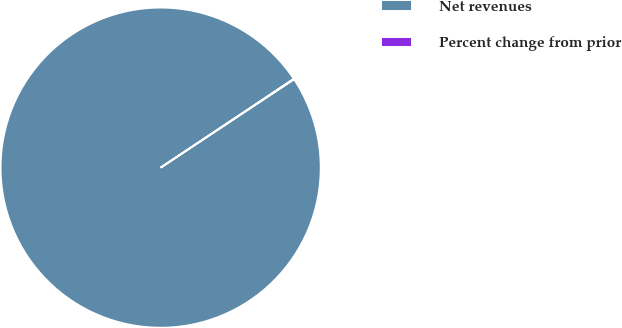Convert chart to OTSL. <chart><loc_0><loc_0><loc_500><loc_500><pie_chart><fcel>Net revenues<fcel>Percent change from prior<nl><fcel>99.95%<fcel>0.05%<nl></chart> 